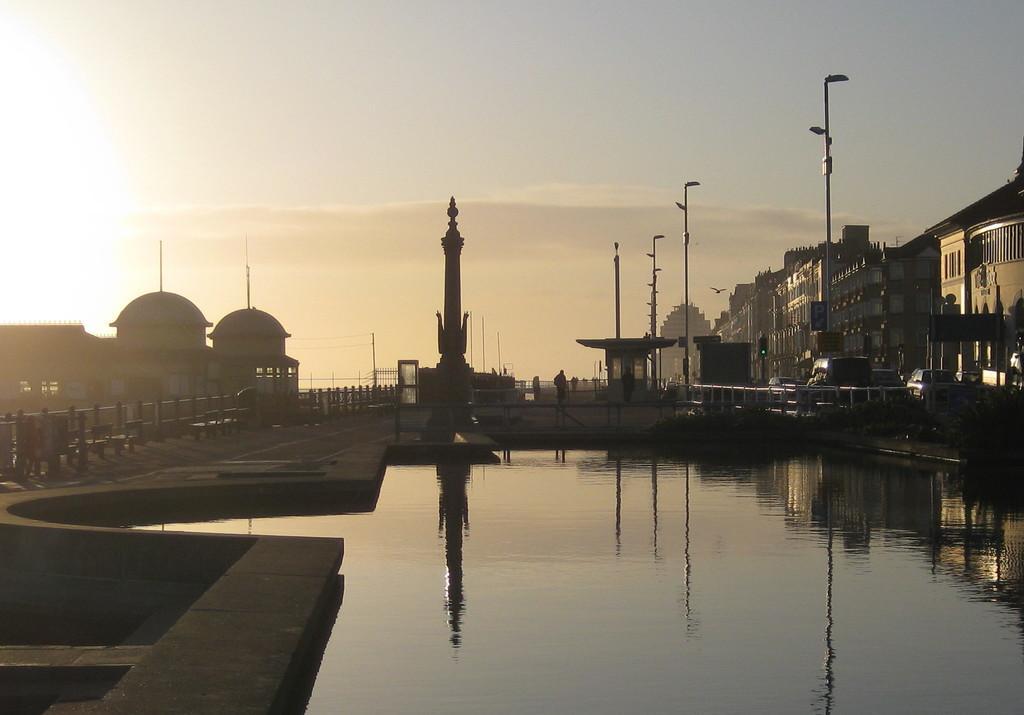Can you describe this image briefly? In this picture we can see water and fence, in the background we can see few poles, vehicles and buildings. 